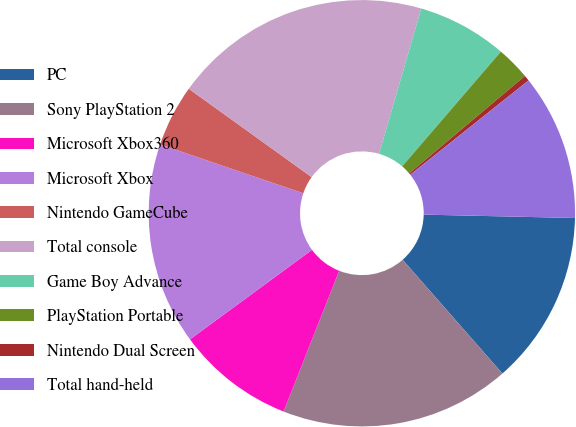<chart> <loc_0><loc_0><loc_500><loc_500><pie_chart><fcel>PC<fcel>Sony PlayStation 2<fcel>Microsoft Xbox360<fcel>Microsoft Xbox<fcel>Nintendo GameCube<fcel>Total console<fcel>Game Boy Advance<fcel>PlayStation Portable<fcel>Nintendo Dual Screen<fcel>Total hand-held<nl><fcel>13.19%<fcel>17.44%<fcel>8.94%<fcel>15.31%<fcel>4.69%<fcel>19.57%<fcel>6.81%<fcel>2.56%<fcel>0.43%<fcel>11.06%<nl></chart> 